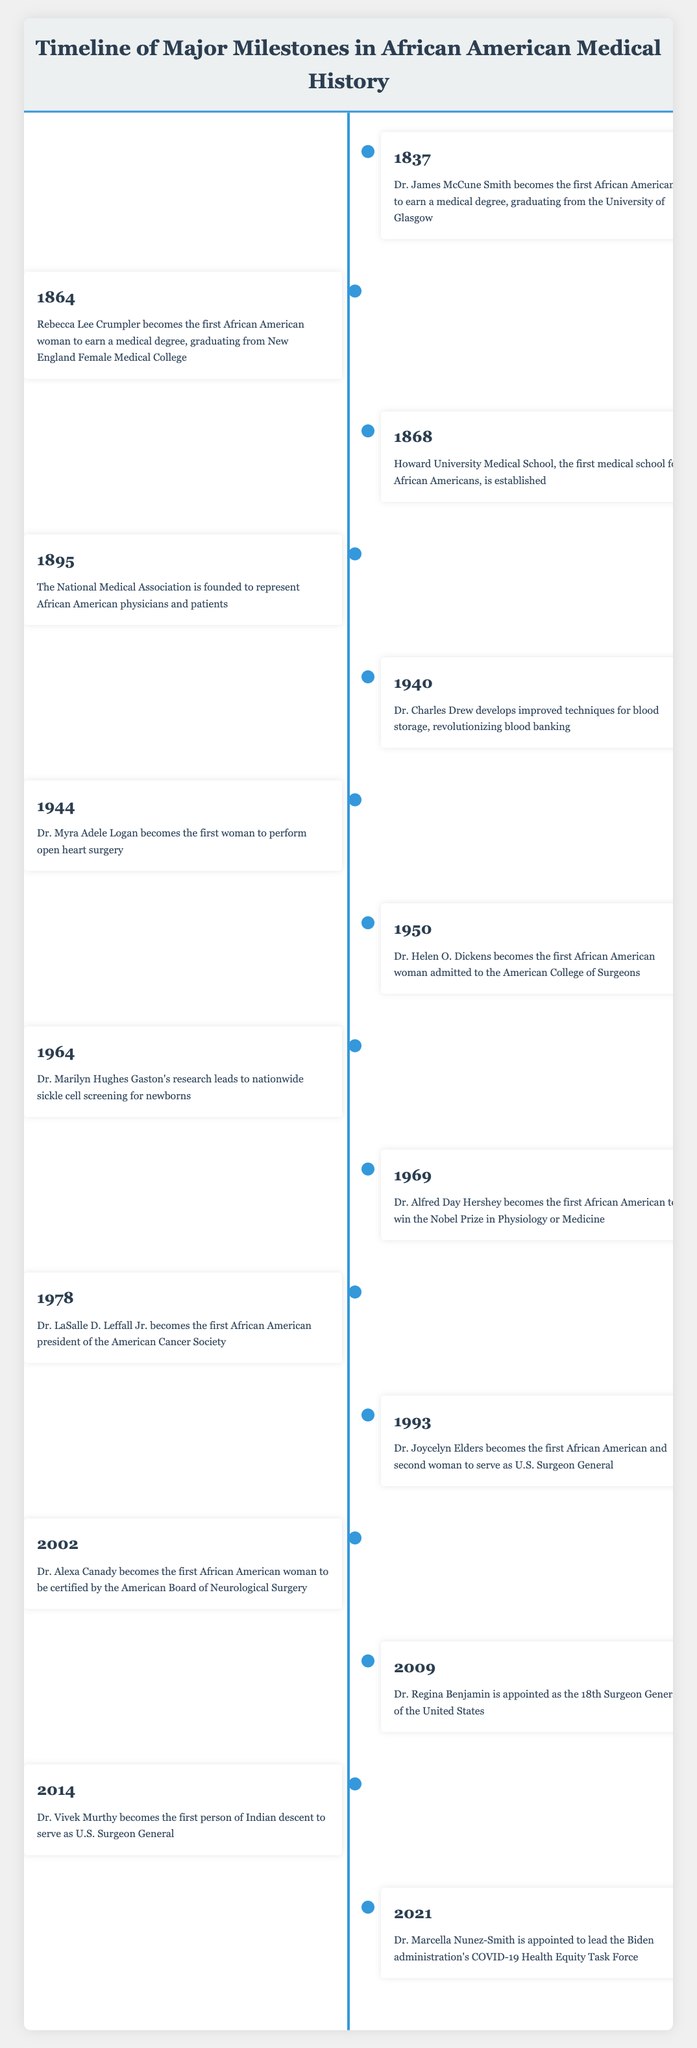What year did Dr. James McCune Smith earn his medical degree? The table indicates that Dr. James McCune Smith earned his medical degree in the year 1837.
Answer: 1837 Who was the first African American woman to earn a medical degree? According to the table, Rebecca Lee Crumpler was the first African American woman to earn a medical degree, graduating in 1864.
Answer: Rebecca Lee Crumpler What significant event occurred in 1944? The table shows that in 1944, Dr. Myra Adele Logan became the first woman to perform open heart surgery, marking a critical milestone.
Answer: Dr. Myra Adele Logan performed open heart surgery How many years passed between the establishment of Howard University Medical School and the founding of the National Medical Association? Howard University Medical School was established in 1868, and the National Medical Association was founded in 1895. The difference is 1895 - 1868 = 27 years.
Answer: 27 years Was Dr. Alfred Day Hershey the first African American to win the Nobel Prize in Physiology or Medicine? Yes, the table confirms that Dr. Alfred Day Hershey became the first African American to win the Nobel Prize in Physiology or Medicine in 1969.
Answer: Yes Which event represents a significant contribution to blood banking? The table states that in 1940, Dr. Charles Drew developed improved techniques for blood storage, which revolutionized blood banking.
Answer: Dr. Charles Drew's techniques for blood storage Who were the first two African Americans to hold significant positions in the U.S. Surgeon General's office? The table lists Dr. Joycelyn Elders, who was the first African American Surgeon General in 1993, and Dr. Regina Benjamin, who was appointed as the Surgeon General in 2009. Thus, the answer is Dr. Joycelyn Elders and Dr. Regina Benjamin.
Answer: Dr. Joycelyn Elders and Dr. Regina Benjamin What milestones involved the American College of Surgeons? The table indicates that Dr. Helen O. Dickens was the first African American woman admitted to the American College of Surgeons in 1950 and suggests a significant milestone for representation within the field.
Answer: Dr. Helen O. Dickens' admission in 1950 